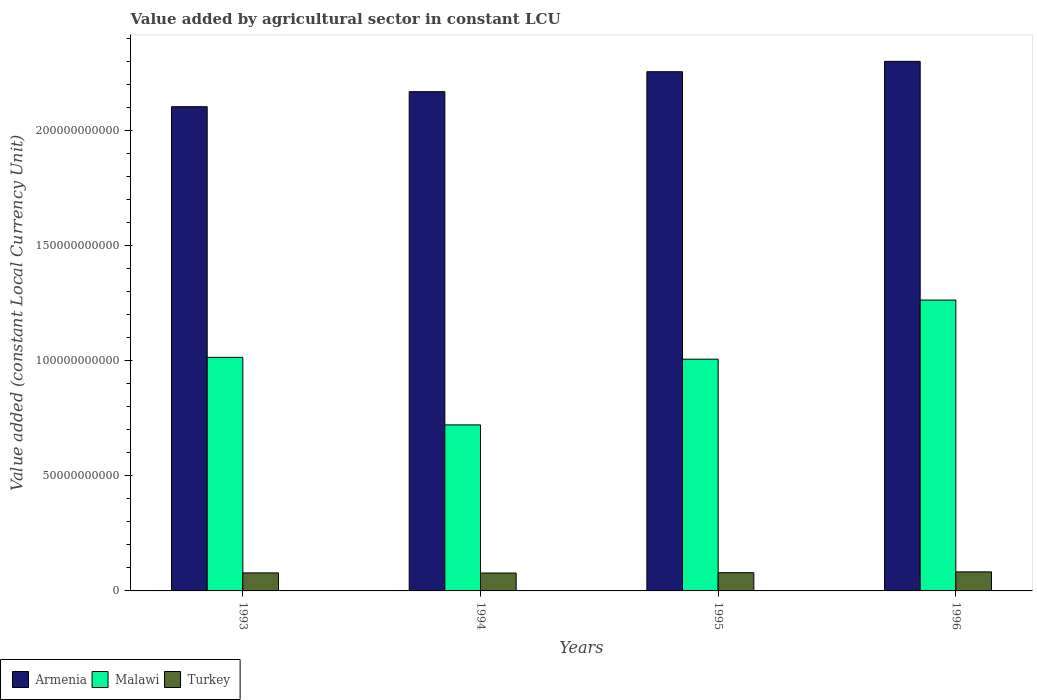Are the number of bars on each tick of the X-axis equal?
Your answer should be very brief. Yes. How many bars are there on the 4th tick from the left?
Your answer should be very brief. 3. What is the value added by agricultural sector in Turkey in 1996?
Your response must be concise. 8.27e+09. Across all years, what is the maximum value added by agricultural sector in Malawi?
Provide a succinct answer. 1.26e+11. Across all years, what is the minimum value added by agricultural sector in Armenia?
Your response must be concise. 2.10e+11. In which year was the value added by agricultural sector in Armenia maximum?
Give a very brief answer. 1996. In which year was the value added by agricultural sector in Malawi minimum?
Provide a succinct answer. 1994. What is the total value added by agricultural sector in Turkey in the graph?
Keep it short and to the point. 3.18e+1. What is the difference between the value added by agricultural sector in Malawi in 1994 and that in 1996?
Keep it short and to the point. -5.42e+1. What is the difference between the value added by agricultural sector in Malawi in 1993 and the value added by agricultural sector in Turkey in 1995?
Keep it short and to the point. 9.35e+1. What is the average value added by agricultural sector in Malawi per year?
Give a very brief answer. 1.00e+11. In the year 1993, what is the difference between the value added by agricultural sector in Malawi and value added by agricultural sector in Armenia?
Ensure brevity in your answer.  -1.09e+11. What is the ratio of the value added by agricultural sector in Turkey in 1994 to that in 1996?
Your answer should be compact. 0.94. Is the difference between the value added by agricultural sector in Malawi in 1993 and 1995 greater than the difference between the value added by agricultural sector in Armenia in 1993 and 1995?
Make the answer very short. Yes. What is the difference between the highest and the second highest value added by agricultural sector in Malawi?
Provide a succinct answer. 2.49e+1. What is the difference between the highest and the lowest value added by agricultural sector in Armenia?
Ensure brevity in your answer.  1.97e+1. Is the sum of the value added by agricultural sector in Armenia in 1994 and 1995 greater than the maximum value added by agricultural sector in Turkey across all years?
Make the answer very short. Yes. What does the 2nd bar from the left in 1996 represents?
Give a very brief answer. Malawi. What does the 2nd bar from the right in 1994 represents?
Offer a very short reply. Malawi. What is the difference between two consecutive major ticks on the Y-axis?
Your response must be concise. 5.00e+1. Does the graph contain grids?
Offer a terse response. No. Where does the legend appear in the graph?
Give a very brief answer. Bottom left. How are the legend labels stacked?
Your answer should be very brief. Horizontal. What is the title of the graph?
Offer a terse response. Value added by agricultural sector in constant LCU. Does "Kazakhstan" appear as one of the legend labels in the graph?
Offer a terse response. No. What is the label or title of the Y-axis?
Provide a short and direct response. Value added (constant Local Currency Unit). What is the Value added (constant Local Currency Unit) of Armenia in 1993?
Keep it short and to the point. 2.10e+11. What is the Value added (constant Local Currency Unit) of Malawi in 1993?
Offer a terse response. 1.01e+11. What is the Value added (constant Local Currency Unit) of Turkey in 1993?
Keep it short and to the point. 7.83e+09. What is the Value added (constant Local Currency Unit) in Armenia in 1994?
Provide a short and direct response. 2.17e+11. What is the Value added (constant Local Currency Unit) in Malawi in 1994?
Offer a very short reply. 7.21e+1. What is the Value added (constant Local Currency Unit) of Turkey in 1994?
Give a very brief answer. 7.77e+09. What is the Value added (constant Local Currency Unit) of Armenia in 1995?
Offer a terse response. 2.26e+11. What is the Value added (constant Local Currency Unit) of Malawi in 1995?
Offer a very short reply. 1.01e+11. What is the Value added (constant Local Currency Unit) of Turkey in 1995?
Provide a succinct answer. 7.93e+09. What is the Value added (constant Local Currency Unit) of Armenia in 1996?
Provide a succinct answer. 2.30e+11. What is the Value added (constant Local Currency Unit) in Malawi in 1996?
Provide a succinct answer. 1.26e+11. What is the Value added (constant Local Currency Unit) in Turkey in 1996?
Provide a succinct answer. 8.27e+09. Across all years, what is the maximum Value added (constant Local Currency Unit) in Armenia?
Your answer should be very brief. 2.30e+11. Across all years, what is the maximum Value added (constant Local Currency Unit) in Malawi?
Your response must be concise. 1.26e+11. Across all years, what is the maximum Value added (constant Local Currency Unit) of Turkey?
Make the answer very short. 8.27e+09. Across all years, what is the minimum Value added (constant Local Currency Unit) of Armenia?
Your answer should be compact. 2.10e+11. Across all years, what is the minimum Value added (constant Local Currency Unit) in Malawi?
Your answer should be compact. 7.21e+1. Across all years, what is the minimum Value added (constant Local Currency Unit) of Turkey?
Provide a short and direct response. 7.77e+09. What is the total Value added (constant Local Currency Unit) in Armenia in the graph?
Your answer should be very brief. 8.83e+11. What is the total Value added (constant Local Currency Unit) of Malawi in the graph?
Your answer should be very brief. 4.01e+11. What is the total Value added (constant Local Currency Unit) of Turkey in the graph?
Provide a short and direct response. 3.18e+1. What is the difference between the Value added (constant Local Currency Unit) in Armenia in 1993 and that in 1994?
Your response must be concise. -6.52e+09. What is the difference between the Value added (constant Local Currency Unit) of Malawi in 1993 and that in 1994?
Make the answer very short. 2.93e+1. What is the difference between the Value added (constant Local Currency Unit) of Turkey in 1993 and that in 1994?
Provide a succinct answer. 5.67e+07. What is the difference between the Value added (constant Local Currency Unit) of Armenia in 1993 and that in 1995?
Your response must be concise. -1.52e+1. What is the difference between the Value added (constant Local Currency Unit) in Malawi in 1993 and that in 1995?
Keep it short and to the point. 7.92e+08. What is the difference between the Value added (constant Local Currency Unit) in Turkey in 1993 and that in 1995?
Your answer should be compact. -9.60e+07. What is the difference between the Value added (constant Local Currency Unit) in Armenia in 1993 and that in 1996?
Make the answer very short. -1.97e+1. What is the difference between the Value added (constant Local Currency Unit) of Malawi in 1993 and that in 1996?
Provide a succinct answer. -2.49e+1. What is the difference between the Value added (constant Local Currency Unit) of Turkey in 1993 and that in 1996?
Offer a very short reply. -4.45e+08. What is the difference between the Value added (constant Local Currency Unit) in Armenia in 1994 and that in 1995?
Offer a very short reply. -8.68e+09. What is the difference between the Value added (constant Local Currency Unit) in Malawi in 1994 and that in 1995?
Provide a succinct answer. -2.86e+1. What is the difference between the Value added (constant Local Currency Unit) of Turkey in 1994 and that in 1995?
Your answer should be compact. -1.53e+08. What is the difference between the Value added (constant Local Currency Unit) in Armenia in 1994 and that in 1996?
Your answer should be very brief. -1.32e+1. What is the difference between the Value added (constant Local Currency Unit) in Malawi in 1994 and that in 1996?
Offer a terse response. -5.42e+1. What is the difference between the Value added (constant Local Currency Unit) of Turkey in 1994 and that in 1996?
Give a very brief answer. -5.01e+08. What is the difference between the Value added (constant Local Currency Unit) of Armenia in 1995 and that in 1996?
Keep it short and to the point. -4.50e+09. What is the difference between the Value added (constant Local Currency Unit) of Malawi in 1995 and that in 1996?
Your answer should be compact. -2.57e+1. What is the difference between the Value added (constant Local Currency Unit) in Turkey in 1995 and that in 1996?
Provide a short and direct response. -3.49e+08. What is the difference between the Value added (constant Local Currency Unit) in Armenia in 1993 and the Value added (constant Local Currency Unit) in Malawi in 1994?
Ensure brevity in your answer.  1.38e+11. What is the difference between the Value added (constant Local Currency Unit) of Armenia in 1993 and the Value added (constant Local Currency Unit) of Turkey in 1994?
Your answer should be very brief. 2.03e+11. What is the difference between the Value added (constant Local Currency Unit) in Malawi in 1993 and the Value added (constant Local Currency Unit) in Turkey in 1994?
Give a very brief answer. 9.37e+1. What is the difference between the Value added (constant Local Currency Unit) of Armenia in 1993 and the Value added (constant Local Currency Unit) of Malawi in 1995?
Keep it short and to the point. 1.10e+11. What is the difference between the Value added (constant Local Currency Unit) in Armenia in 1993 and the Value added (constant Local Currency Unit) in Turkey in 1995?
Your response must be concise. 2.02e+11. What is the difference between the Value added (constant Local Currency Unit) in Malawi in 1993 and the Value added (constant Local Currency Unit) in Turkey in 1995?
Offer a very short reply. 9.35e+1. What is the difference between the Value added (constant Local Currency Unit) of Armenia in 1993 and the Value added (constant Local Currency Unit) of Malawi in 1996?
Keep it short and to the point. 8.40e+1. What is the difference between the Value added (constant Local Currency Unit) of Armenia in 1993 and the Value added (constant Local Currency Unit) of Turkey in 1996?
Provide a succinct answer. 2.02e+11. What is the difference between the Value added (constant Local Currency Unit) in Malawi in 1993 and the Value added (constant Local Currency Unit) in Turkey in 1996?
Offer a terse response. 9.32e+1. What is the difference between the Value added (constant Local Currency Unit) in Armenia in 1994 and the Value added (constant Local Currency Unit) in Malawi in 1995?
Make the answer very short. 1.16e+11. What is the difference between the Value added (constant Local Currency Unit) of Armenia in 1994 and the Value added (constant Local Currency Unit) of Turkey in 1995?
Your answer should be very brief. 2.09e+11. What is the difference between the Value added (constant Local Currency Unit) in Malawi in 1994 and the Value added (constant Local Currency Unit) in Turkey in 1995?
Your answer should be very brief. 6.42e+1. What is the difference between the Value added (constant Local Currency Unit) in Armenia in 1994 and the Value added (constant Local Currency Unit) in Malawi in 1996?
Offer a very short reply. 9.05e+1. What is the difference between the Value added (constant Local Currency Unit) of Armenia in 1994 and the Value added (constant Local Currency Unit) of Turkey in 1996?
Ensure brevity in your answer.  2.09e+11. What is the difference between the Value added (constant Local Currency Unit) in Malawi in 1994 and the Value added (constant Local Currency Unit) in Turkey in 1996?
Offer a terse response. 6.39e+1. What is the difference between the Value added (constant Local Currency Unit) of Armenia in 1995 and the Value added (constant Local Currency Unit) of Malawi in 1996?
Make the answer very short. 9.92e+1. What is the difference between the Value added (constant Local Currency Unit) of Armenia in 1995 and the Value added (constant Local Currency Unit) of Turkey in 1996?
Give a very brief answer. 2.17e+11. What is the difference between the Value added (constant Local Currency Unit) of Malawi in 1995 and the Value added (constant Local Currency Unit) of Turkey in 1996?
Give a very brief answer. 9.24e+1. What is the average Value added (constant Local Currency Unit) of Armenia per year?
Make the answer very short. 2.21e+11. What is the average Value added (constant Local Currency Unit) of Malawi per year?
Offer a very short reply. 1.00e+11. What is the average Value added (constant Local Currency Unit) of Turkey per year?
Keep it short and to the point. 7.95e+09. In the year 1993, what is the difference between the Value added (constant Local Currency Unit) in Armenia and Value added (constant Local Currency Unit) in Malawi?
Your response must be concise. 1.09e+11. In the year 1993, what is the difference between the Value added (constant Local Currency Unit) in Armenia and Value added (constant Local Currency Unit) in Turkey?
Ensure brevity in your answer.  2.03e+11. In the year 1993, what is the difference between the Value added (constant Local Currency Unit) in Malawi and Value added (constant Local Currency Unit) in Turkey?
Provide a succinct answer. 9.36e+1. In the year 1994, what is the difference between the Value added (constant Local Currency Unit) of Armenia and Value added (constant Local Currency Unit) of Malawi?
Offer a very short reply. 1.45e+11. In the year 1994, what is the difference between the Value added (constant Local Currency Unit) of Armenia and Value added (constant Local Currency Unit) of Turkey?
Provide a succinct answer. 2.09e+11. In the year 1994, what is the difference between the Value added (constant Local Currency Unit) of Malawi and Value added (constant Local Currency Unit) of Turkey?
Ensure brevity in your answer.  6.44e+1. In the year 1995, what is the difference between the Value added (constant Local Currency Unit) in Armenia and Value added (constant Local Currency Unit) in Malawi?
Offer a very short reply. 1.25e+11. In the year 1995, what is the difference between the Value added (constant Local Currency Unit) of Armenia and Value added (constant Local Currency Unit) of Turkey?
Provide a short and direct response. 2.18e+11. In the year 1995, what is the difference between the Value added (constant Local Currency Unit) in Malawi and Value added (constant Local Currency Unit) in Turkey?
Make the answer very short. 9.28e+1. In the year 1996, what is the difference between the Value added (constant Local Currency Unit) of Armenia and Value added (constant Local Currency Unit) of Malawi?
Provide a short and direct response. 1.04e+11. In the year 1996, what is the difference between the Value added (constant Local Currency Unit) in Armenia and Value added (constant Local Currency Unit) in Turkey?
Your response must be concise. 2.22e+11. In the year 1996, what is the difference between the Value added (constant Local Currency Unit) of Malawi and Value added (constant Local Currency Unit) of Turkey?
Give a very brief answer. 1.18e+11. What is the ratio of the Value added (constant Local Currency Unit) in Armenia in 1993 to that in 1994?
Keep it short and to the point. 0.97. What is the ratio of the Value added (constant Local Currency Unit) in Malawi in 1993 to that in 1994?
Ensure brevity in your answer.  1.41. What is the ratio of the Value added (constant Local Currency Unit) of Turkey in 1993 to that in 1994?
Offer a very short reply. 1.01. What is the ratio of the Value added (constant Local Currency Unit) in Armenia in 1993 to that in 1995?
Keep it short and to the point. 0.93. What is the ratio of the Value added (constant Local Currency Unit) of Malawi in 1993 to that in 1995?
Give a very brief answer. 1.01. What is the ratio of the Value added (constant Local Currency Unit) of Turkey in 1993 to that in 1995?
Your response must be concise. 0.99. What is the ratio of the Value added (constant Local Currency Unit) in Armenia in 1993 to that in 1996?
Your answer should be compact. 0.91. What is the ratio of the Value added (constant Local Currency Unit) in Malawi in 1993 to that in 1996?
Your answer should be compact. 0.8. What is the ratio of the Value added (constant Local Currency Unit) in Turkey in 1993 to that in 1996?
Ensure brevity in your answer.  0.95. What is the ratio of the Value added (constant Local Currency Unit) in Armenia in 1994 to that in 1995?
Keep it short and to the point. 0.96. What is the ratio of the Value added (constant Local Currency Unit) of Malawi in 1994 to that in 1995?
Make the answer very short. 0.72. What is the ratio of the Value added (constant Local Currency Unit) of Turkey in 1994 to that in 1995?
Offer a very short reply. 0.98. What is the ratio of the Value added (constant Local Currency Unit) of Armenia in 1994 to that in 1996?
Make the answer very short. 0.94. What is the ratio of the Value added (constant Local Currency Unit) of Malawi in 1994 to that in 1996?
Ensure brevity in your answer.  0.57. What is the ratio of the Value added (constant Local Currency Unit) in Turkey in 1994 to that in 1996?
Provide a succinct answer. 0.94. What is the ratio of the Value added (constant Local Currency Unit) in Armenia in 1995 to that in 1996?
Offer a terse response. 0.98. What is the ratio of the Value added (constant Local Currency Unit) in Malawi in 1995 to that in 1996?
Your answer should be compact. 0.8. What is the ratio of the Value added (constant Local Currency Unit) of Turkey in 1995 to that in 1996?
Your answer should be compact. 0.96. What is the difference between the highest and the second highest Value added (constant Local Currency Unit) of Armenia?
Your answer should be very brief. 4.50e+09. What is the difference between the highest and the second highest Value added (constant Local Currency Unit) in Malawi?
Provide a succinct answer. 2.49e+1. What is the difference between the highest and the second highest Value added (constant Local Currency Unit) in Turkey?
Ensure brevity in your answer.  3.49e+08. What is the difference between the highest and the lowest Value added (constant Local Currency Unit) of Armenia?
Ensure brevity in your answer.  1.97e+1. What is the difference between the highest and the lowest Value added (constant Local Currency Unit) of Malawi?
Make the answer very short. 5.42e+1. What is the difference between the highest and the lowest Value added (constant Local Currency Unit) in Turkey?
Offer a terse response. 5.01e+08. 